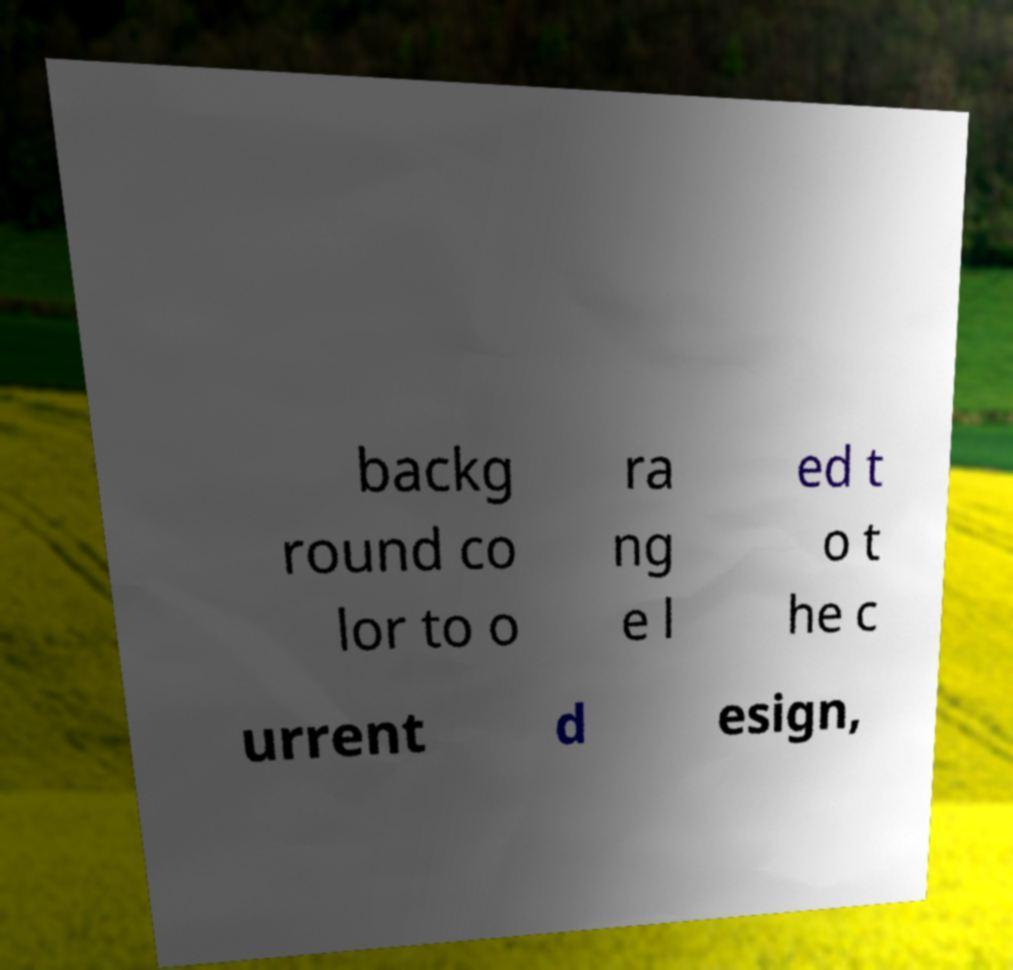Please identify and transcribe the text found in this image. backg round co lor to o ra ng e l ed t o t he c urrent d esign, 